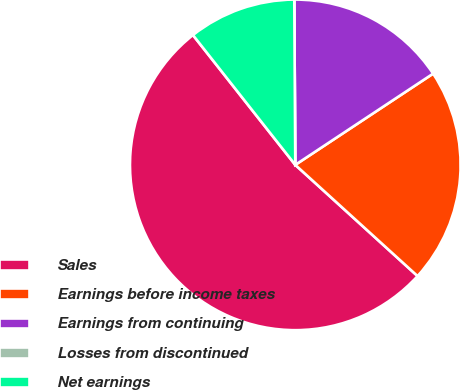<chart> <loc_0><loc_0><loc_500><loc_500><pie_chart><fcel>Sales<fcel>Earnings before income taxes<fcel>Earnings from continuing<fcel>Losses from discontinued<fcel>Net earnings<nl><fcel>52.63%<fcel>21.05%<fcel>15.79%<fcel>0.0%<fcel>10.53%<nl></chart> 